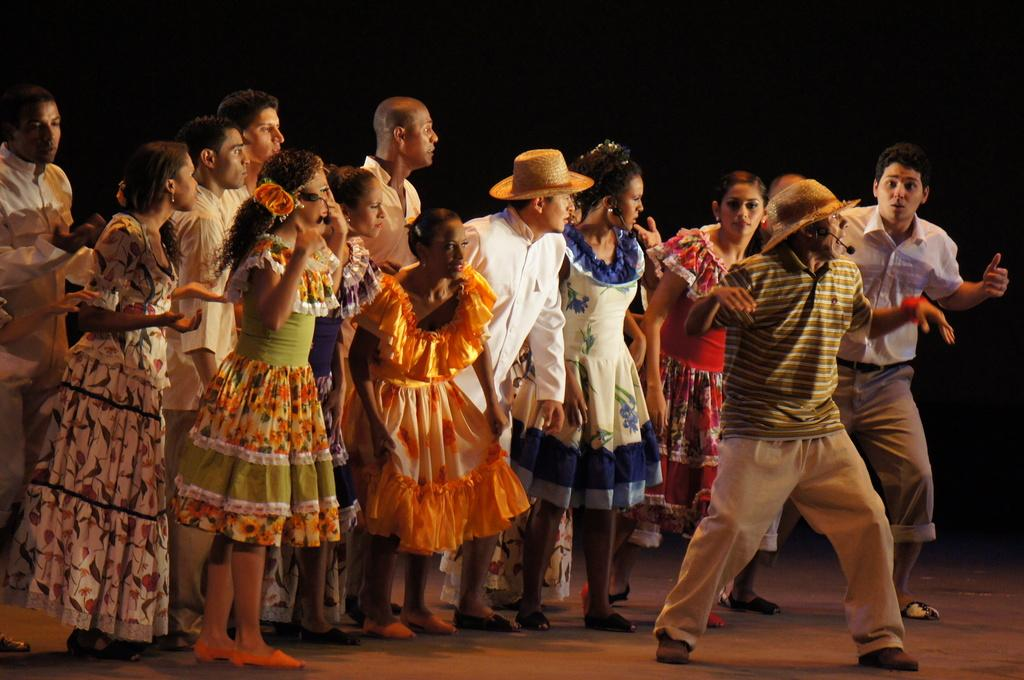What is happening in the center of the image? There are people standing in the center of the image. What are the people wearing? The people are wearing costumes. Can you describe the man on the right side of the image? The man on the right side of the image is wearing a hat. What type of spark can be seen coming from the iron in the image? There is no iron or spark present in the image. Can you tell me how many airplanes are visible in the image? There are no airplanes visible in the image. 